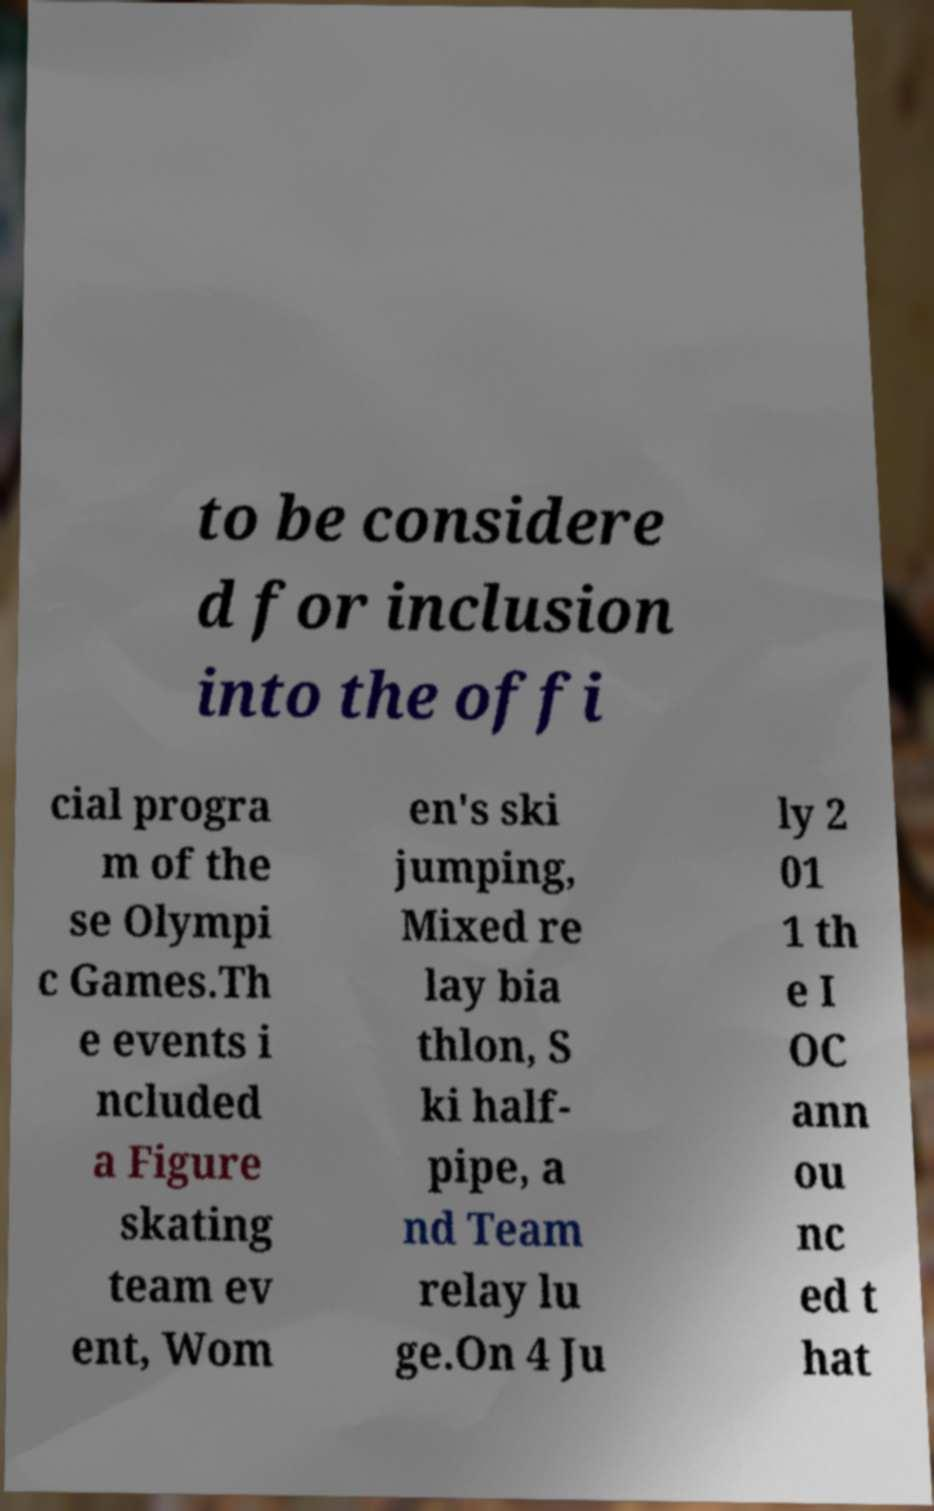Could you assist in decoding the text presented in this image and type it out clearly? to be considere d for inclusion into the offi cial progra m of the se Olympi c Games.Th e events i ncluded a Figure skating team ev ent, Wom en's ski jumping, Mixed re lay bia thlon, S ki half- pipe, a nd Team relay lu ge.On 4 Ju ly 2 01 1 th e I OC ann ou nc ed t hat 